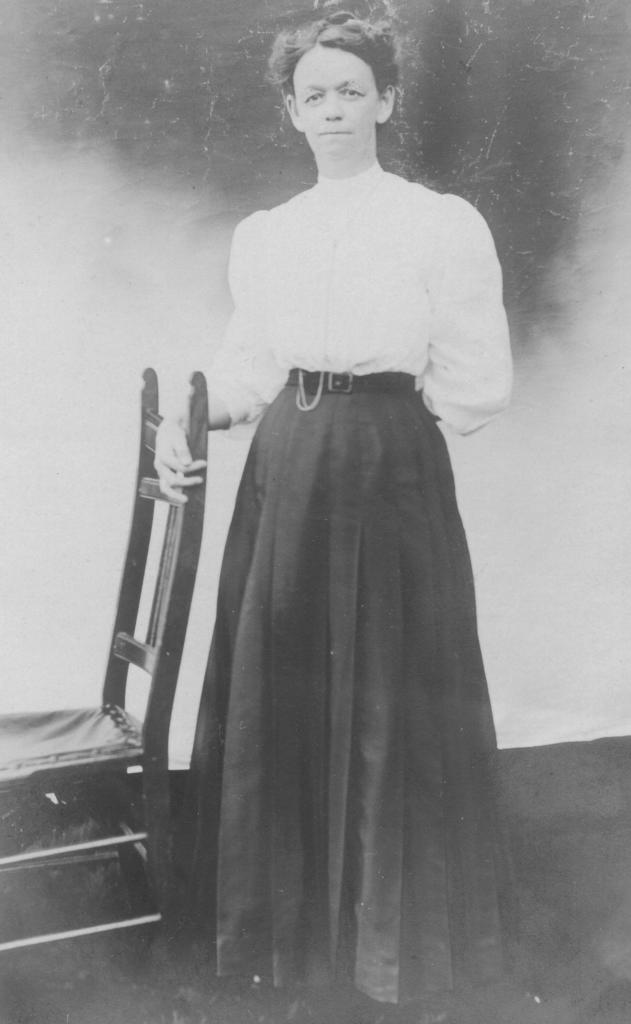Who is present in the image? There is a woman in the image. What is the woman doing in the image? The woman is standing behind a chair and holding it. How many brothers does the woman have in the image? There is no information about the woman's brothers in the image. What is the woman learning in the image? There is no indication of the woman learning anything in the image. 